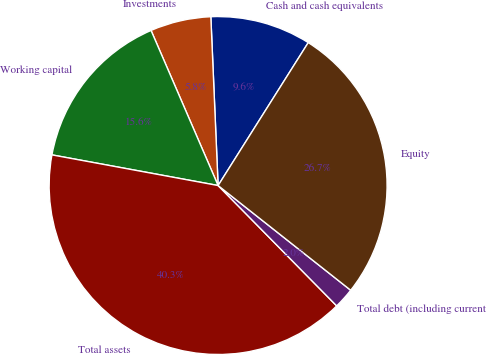Convert chart to OTSL. <chart><loc_0><loc_0><loc_500><loc_500><pie_chart><fcel>Cash and cash equivalents<fcel>Investments<fcel>Working capital<fcel>Total assets<fcel>Total debt (including current<fcel>Equity<nl><fcel>9.64%<fcel>5.81%<fcel>15.6%<fcel>40.28%<fcel>1.98%<fcel>26.68%<nl></chart> 